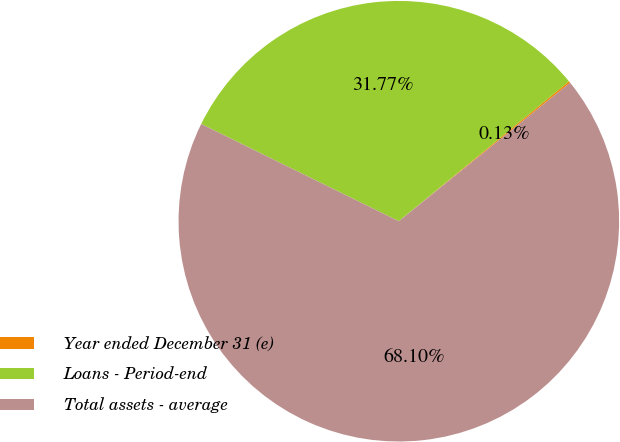Convert chart. <chart><loc_0><loc_0><loc_500><loc_500><pie_chart><fcel>Year ended December 31 (e)<fcel>Loans - Period-end<fcel>Total assets - average<nl><fcel>0.13%<fcel>31.77%<fcel>68.1%<nl></chart> 